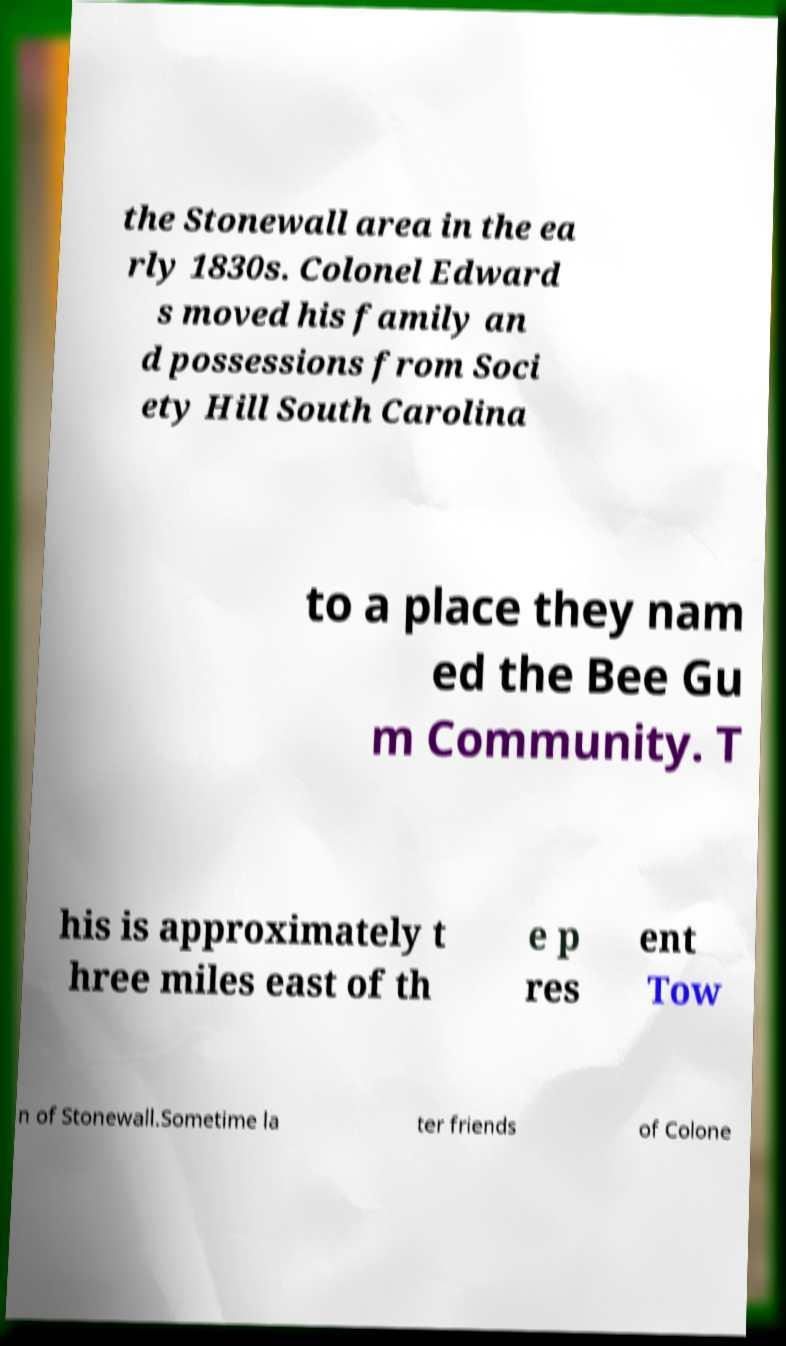There's text embedded in this image that I need extracted. Can you transcribe it verbatim? the Stonewall area in the ea rly 1830s. Colonel Edward s moved his family an d possessions from Soci ety Hill South Carolina to a place they nam ed the Bee Gu m Community. T his is approximately t hree miles east of th e p res ent Tow n of Stonewall.Sometime la ter friends of Colone 